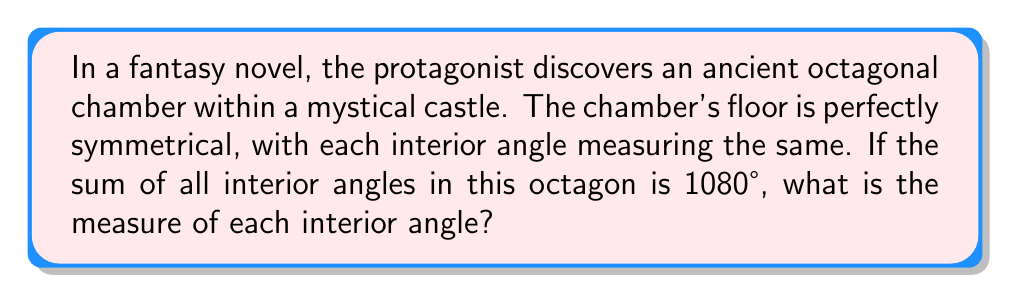Can you solve this math problem? Let's approach this step-by-step:

1) First, recall the formula for the sum of interior angles of a polygon with $n$ sides:

   $S = (n-2) \times 180°$

2) We're given that the sum of interior angles is 1080° and we know it's an octagon, so $n = 8$:

   $1080° = (8-2) \times 180°$

3) This confirms that our octagon is indeed regular (all angles equal).

4) To find each interior angle, we divide the sum by the number of angles:

   $\text{Each angle} = \frac{\text{Sum of angles}}{\text{Number of angles}} = \frac{1080°}{8}$

5) Simplify:
   
   $\frac{1080°}{8} = 135°$

Therefore, each interior angle of the octagonal chamber measures 135°.
Answer: $135°$ 